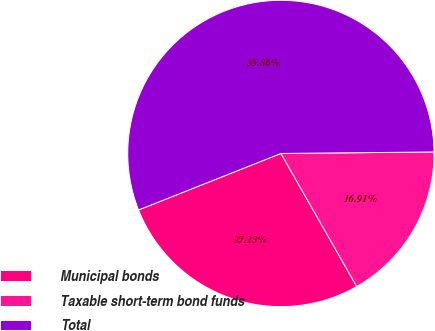Convert chart to OTSL. <chart><loc_0><loc_0><loc_500><loc_500><pie_chart><fcel>Municipal bonds<fcel>Taxable short-term bond funds<fcel>Total<nl><fcel>27.23%<fcel>16.91%<fcel>55.86%<nl></chart> 